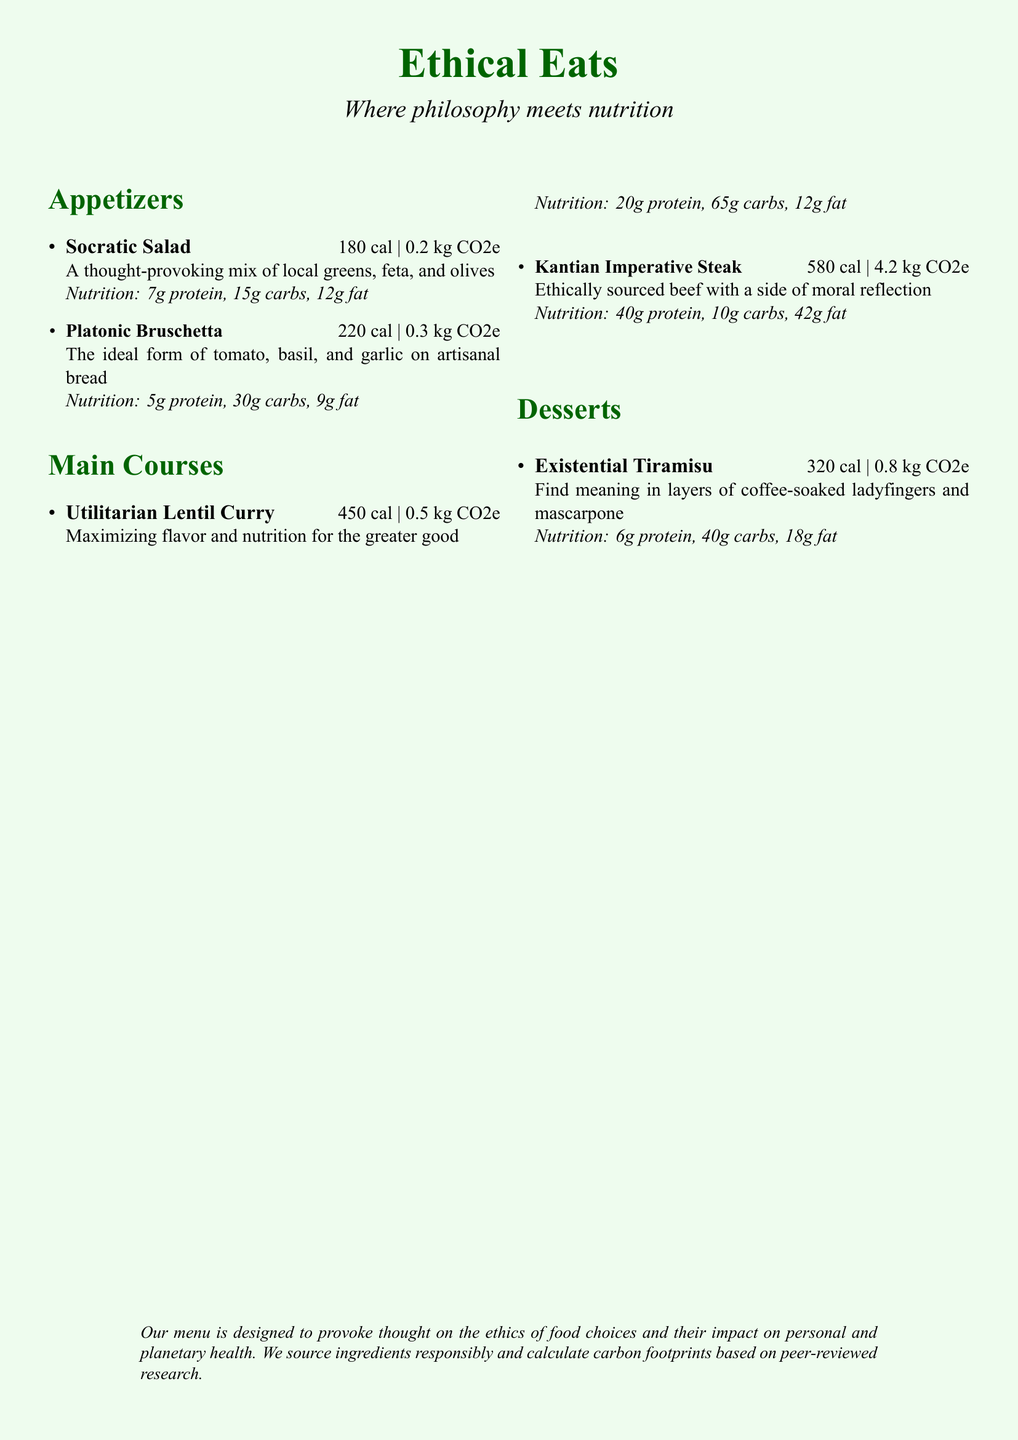What is the calorie content of the Socratic Salad? The calorie content of the Socratic Salad is specified directly in the menu item description.
Answer: 180 cal What is the carbon footprint of the Kantian Imperative Steak? The carbon footprint for the Kantian Imperative Steak is listed right alongside its description in the menu.
Answer: 4.2 kg CO2e How many grams of protein are in the Utilitarian Lentil Curry? The protein content is provided in the nutritional information section of the dish.
Answer: 20g protein What is the total calorie content of the appetizers listed? To calculate the total calorie content, add the calories of the Socratic Salad and Platonic Bruschetta.
Answer: 400 cal Which dish has the highest carbon footprint? By comparing the carbon footprints listed, the dish with the highest value can be identified.
Answer: Kantian Imperative Steak How many carbs are in the Existential Tiramisu? The amount of carbs is specifically mentioned in the nutrition breakdown for the dessert.
Answer: 40g carbs What type of bread is used in the Platonic Bruschetta? This is inferred through the description of the dish in the menu.
Answer: Artisanal bread What ethical approach does the Utilitarian Lentil Curry emphasize? This is found in the description of the dish’s intention or philosophy.
Answer: Maximizing flavor and nutrition for the greater good What is the overarching theme of the restaurant's menu? The theme encapsulated at the top of the menu highlights the restaurant's focus on a particular concept.
Answer: Ethics of food choices and their impact on health 